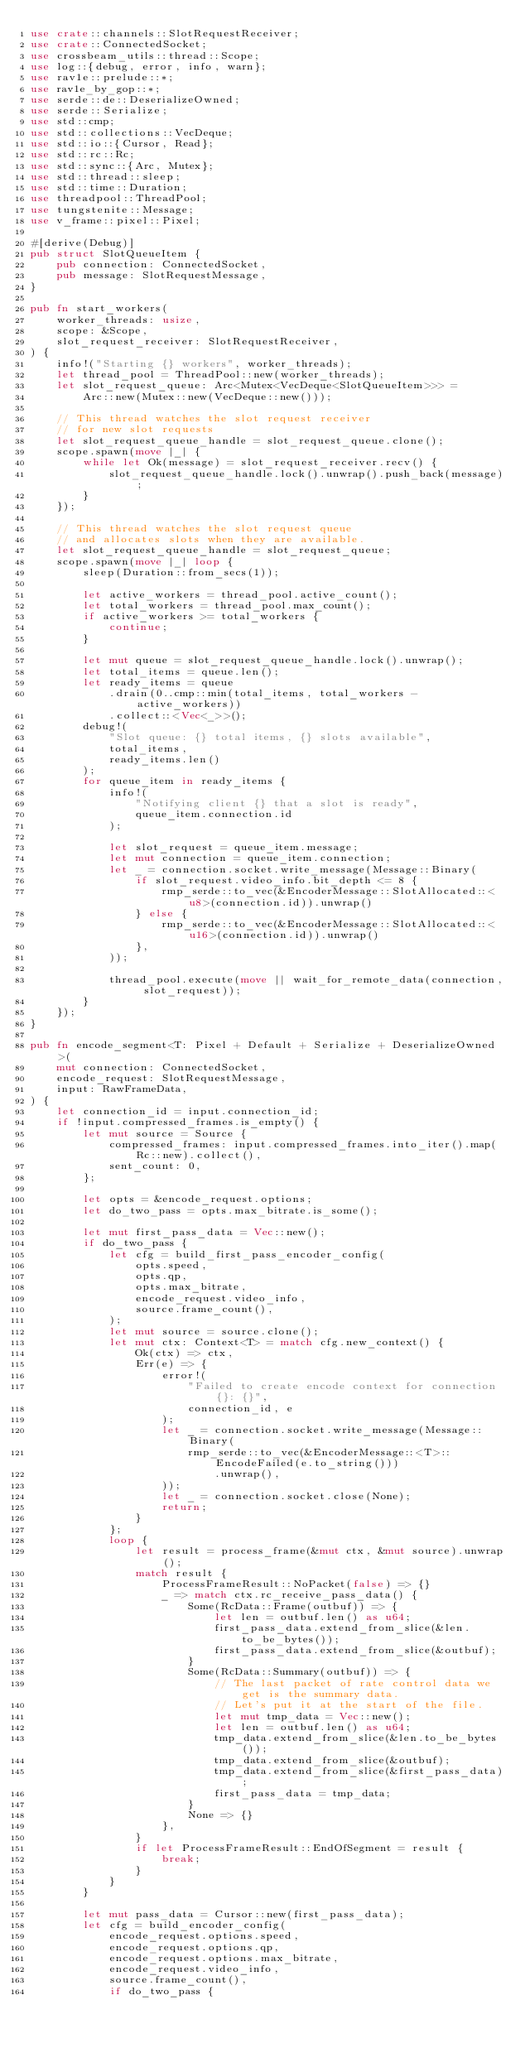Convert code to text. <code><loc_0><loc_0><loc_500><loc_500><_Rust_>use crate::channels::SlotRequestReceiver;
use crate::ConnectedSocket;
use crossbeam_utils::thread::Scope;
use log::{debug, error, info, warn};
use rav1e::prelude::*;
use rav1e_by_gop::*;
use serde::de::DeserializeOwned;
use serde::Serialize;
use std::cmp;
use std::collections::VecDeque;
use std::io::{Cursor, Read};
use std::rc::Rc;
use std::sync::{Arc, Mutex};
use std::thread::sleep;
use std::time::Duration;
use threadpool::ThreadPool;
use tungstenite::Message;
use v_frame::pixel::Pixel;

#[derive(Debug)]
pub struct SlotQueueItem {
    pub connection: ConnectedSocket,
    pub message: SlotRequestMessage,
}

pub fn start_workers(
    worker_threads: usize,
    scope: &Scope,
    slot_request_receiver: SlotRequestReceiver,
) {
    info!("Starting {} workers", worker_threads);
    let thread_pool = ThreadPool::new(worker_threads);
    let slot_request_queue: Arc<Mutex<VecDeque<SlotQueueItem>>> =
        Arc::new(Mutex::new(VecDeque::new()));

    // This thread watches the slot request receiver
    // for new slot requests
    let slot_request_queue_handle = slot_request_queue.clone();
    scope.spawn(move |_| {
        while let Ok(message) = slot_request_receiver.recv() {
            slot_request_queue_handle.lock().unwrap().push_back(message);
        }
    });

    // This thread watches the slot request queue
    // and allocates slots when they are available.
    let slot_request_queue_handle = slot_request_queue;
    scope.spawn(move |_| loop {
        sleep(Duration::from_secs(1));

        let active_workers = thread_pool.active_count();
        let total_workers = thread_pool.max_count();
        if active_workers >= total_workers {
            continue;
        }

        let mut queue = slot_request_queue_handle.lock().unwrap();
        let total_items = queue.len();
        let ready_items = queue
            .drain(0..cmp::min(total_items, total_workers - active_workers))
            .collect::<Vec<_>>();
        debug!(
            "Slot queue: {} total items, {} slots available",
            total_items,
            ready_items.len()
        );
        for queue_item in ready_items {
            info!(
                "Notifying client {} that a slot is ready",
                queue_item.connection.id
            );

            let slot_request = queue_item.message;
            let mut connection = queue_item.connection;
            let _ = connection.socket.write_message(Message::Binary(
                if slot_request.video_info.bit_depth <= 8 {
                    rmp_serde::to_vec(&EncoderMessage::SlotAllocated::<u8>(connection.id)).unwrap()
                } else {
                    rmp_serde::to_vec(&EncoderMessage::SlotAllocated::<u16>(connection.id)).unwrap()
                },
            ));

            thread_pool.execute(move || wait_for_remote_data(connection, slot_request));
        }
    });
}

pub fn encode_segment<T: Pixel + Default + Serialize + DeserializeOwned>(
    mut connection: ConnectedSocket,
    encode_request: SlotRequestMessage,
    input: RawFrameData,
) {
    let connection_id = input.connection_id;
    if !input.compressed_frames.is_empty() {
        let mut source = Source {
            compressed_frames: input.compressed_frames.into_iter().map(Rc::new).collect(),
            sent_count: 0,
        };

        let opts = &encode_request.options;
        let do_two_pass = opts.max_bitrate.is_some();

        let mut first_pass_data = Vec::new();
        if do_two_pass {
            let cfg = build_first_pass_encoder_config(
                opts.speed,
                opts.qp,
                opts.max_bitrate,
                encode_request.video_info,
                source.frame_count(),
            );
            let mut source = source.clone();
            let mut ctx: Context<T> = match cfg.new_context() {
                Ok(ctx) => ctx,
                Err(e) => {
                    error!(
                        "Failed to create encode context for connection {}: {}",
                        connection_id, e
                    );
                    let _ = connection.socket.write_message(Message::Binary(
                        rmp_serde::to_vec(&EncoderMessage::<T>::EncodeFailed(e.to_string()))
                            .unwrap(),
                    ));
                    let _ = connection.socket.close(None);
                    return;
                }
            };
            loop {
                let result = process_frame(&mut ctx, &mut source).unwrap();
                match result {
                    ProcessFrameResult::NoPacket(false) => {}
                    _ => match ctx.rc_receive_pass_data() {
                        Some(RcData::Frame(outbuf)) => {
                            let len = outbuf.len() as u64;
                            first_pass_data.extend_from_slice(&len.to_be_bytes());
                            first_pass_data.extend_from_slice(&outbuf);
                        }
                        Some(RcData::Summary(outbuf)) => {
                            // The last packet of rate control data we get is the summary data.
                            // Let's put it at the start of the file.
                            let mut tmp_data = Vec::new();
                            let len = outbuf.len() as u64;
                            tmp_data.extend_from_slice(&len.to_be_bytes());
                            tmp_data.extend_from_slice(&outbuf);
                            tmp_data.extend_from_slice(&first_pass_data);
                            first_pass_data = tmp_data;
                        }
                        None => {}
                    },
                }
                if let ProcessFrameResult::EndOfSegment = result {
                    break;
                }
            }
        }

        let mut pass_data = Cursor::new(first_pass_data);
        let cfg = build_encoder_config(
            encode_request.options.speed,
            encode_request.options.qp,
            encode_request.options.max_bitrate,
            encode_request.video_info,
            source.frame_count(),
            if do_two_pass {</code> 